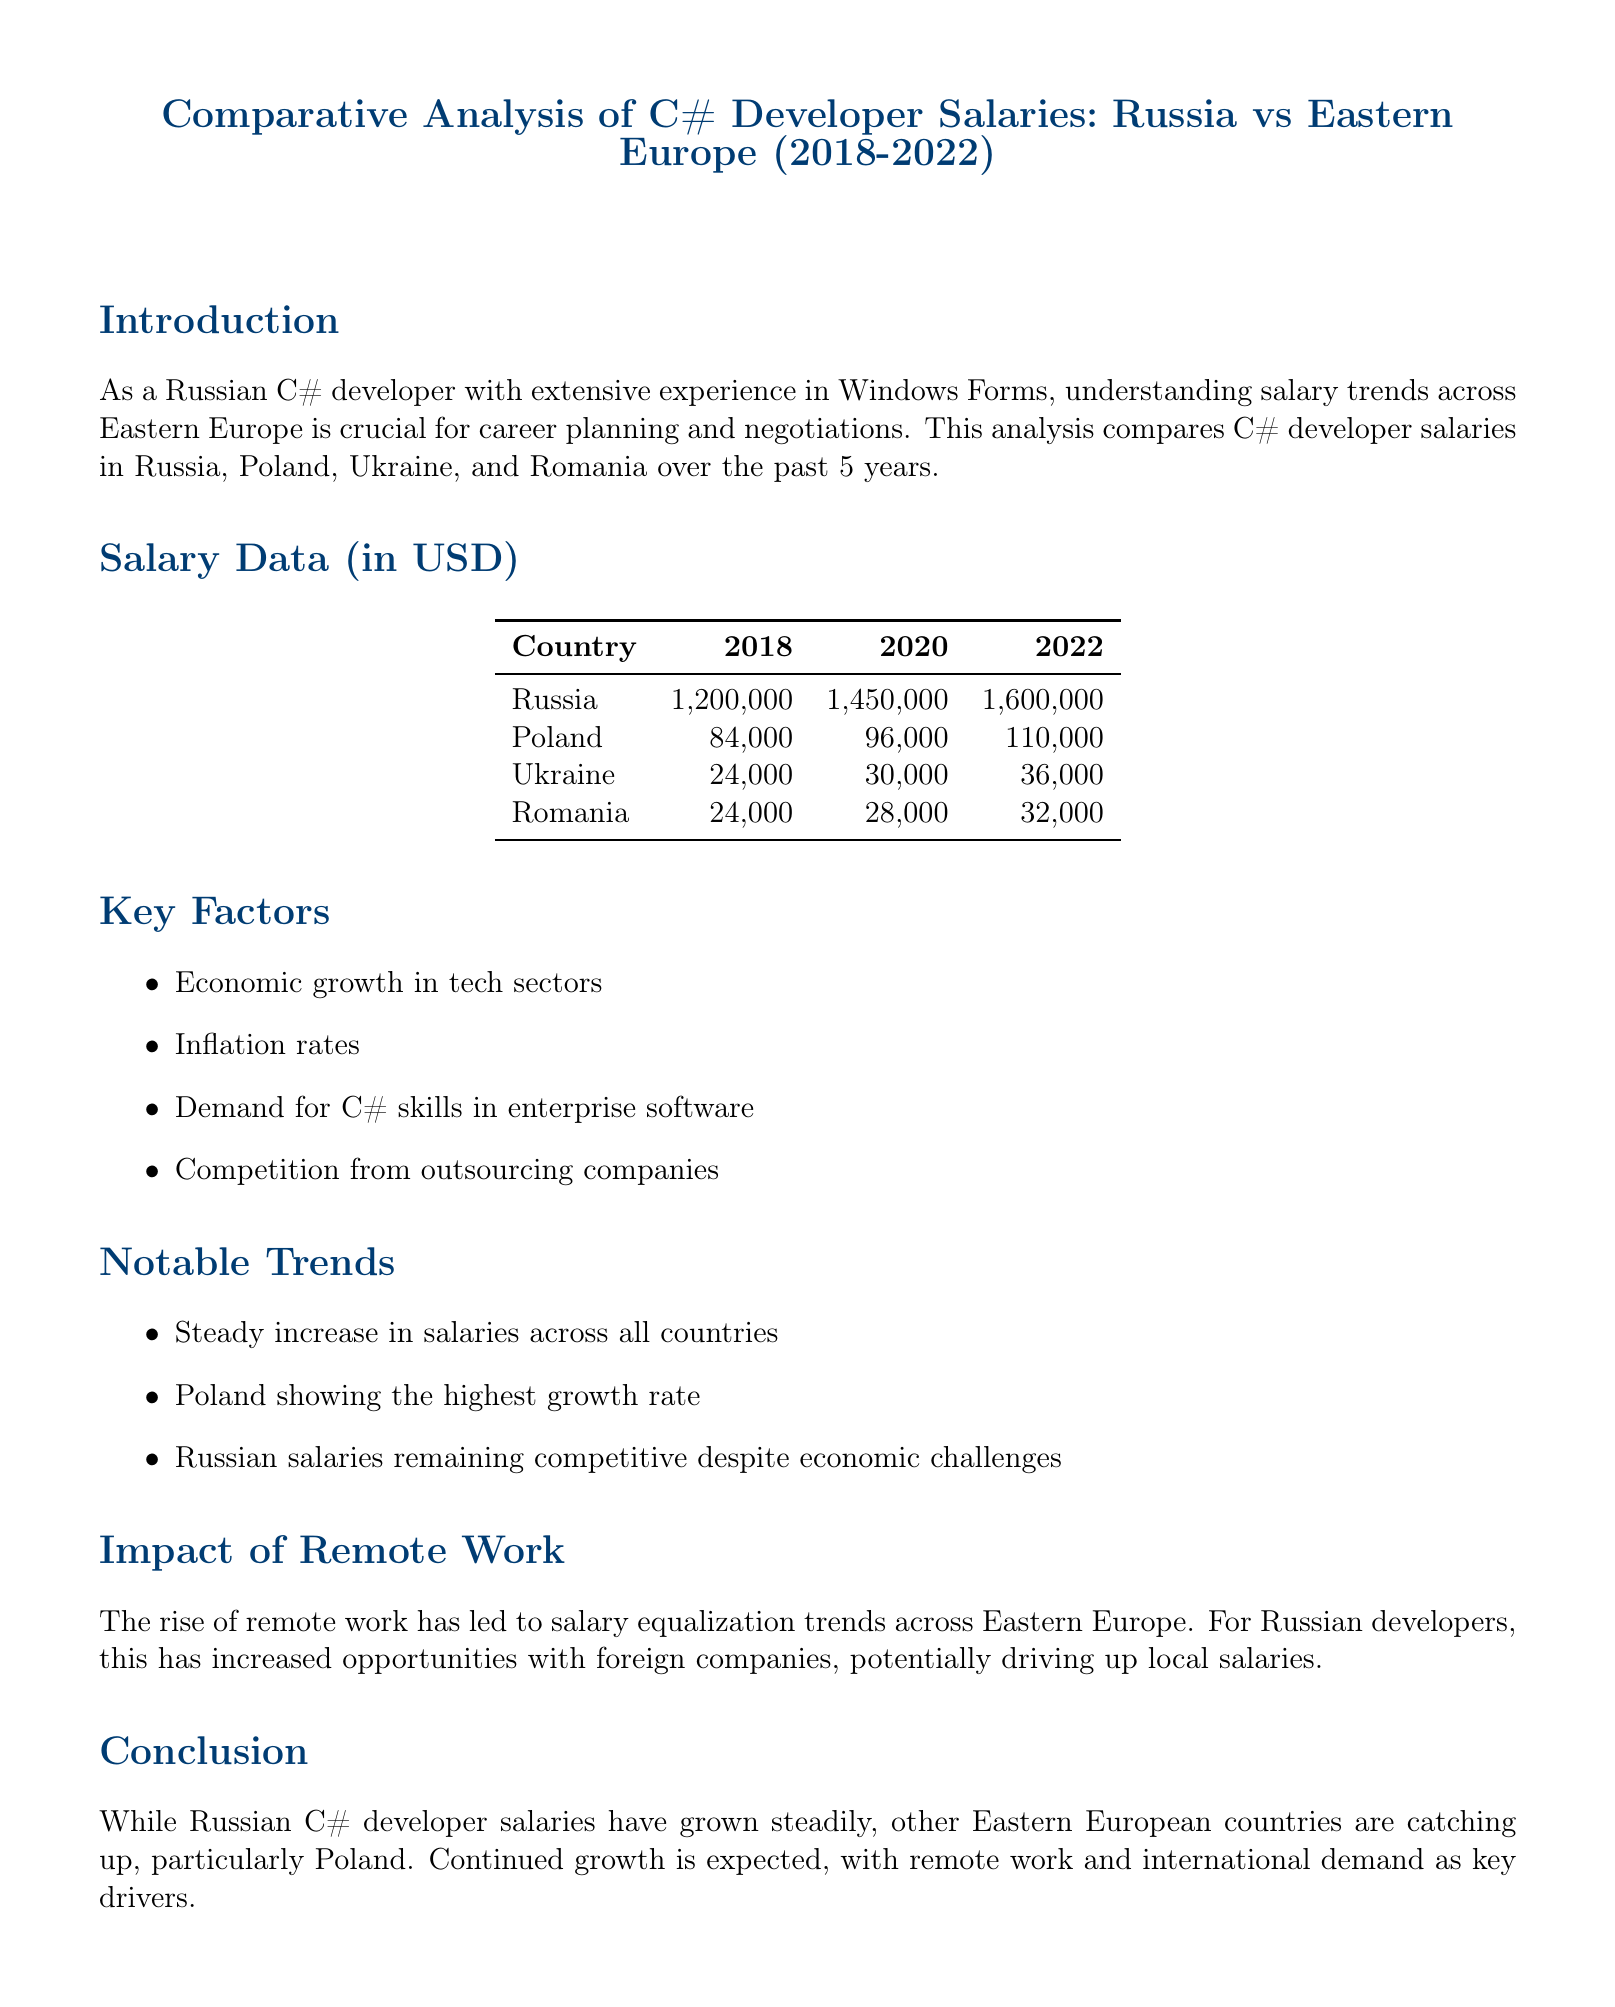what is the title of the document? The title is specified at the beginning of the document.
Answer: Comparative Analysis of C# Developer Salaries: Russia vs Eastern Europe (2018-2022) which country had the highest salary in 2022? The document provides salary data for each country for 2022.
Answer: Russia what was the salary of C# developers in Poland in 2020? The salary data presents numbers for each country in 2020.
Answer: 96000 what trend is noted regarding Polish salaries? The notable trends section identifies specific salary growth patterns.
Answer: Highest growth rate how many key factors influence salary trends? The key factors section lists the elements affecting salary trends.
Answer: Four what overall trend is observed in C# developer salaries across the countries? The document summarizes notable trends regarding salary changes.
Answer: Steady increase what impact did remote work have on Russian developers? The impact of remote work section discusses its consequences for local developers.
Answer: Increased opportunities what is the outlook for C# developer salaries according to the conclusion? The conclusion provides insights into future salary trends.
Answer: Continued growth expected 